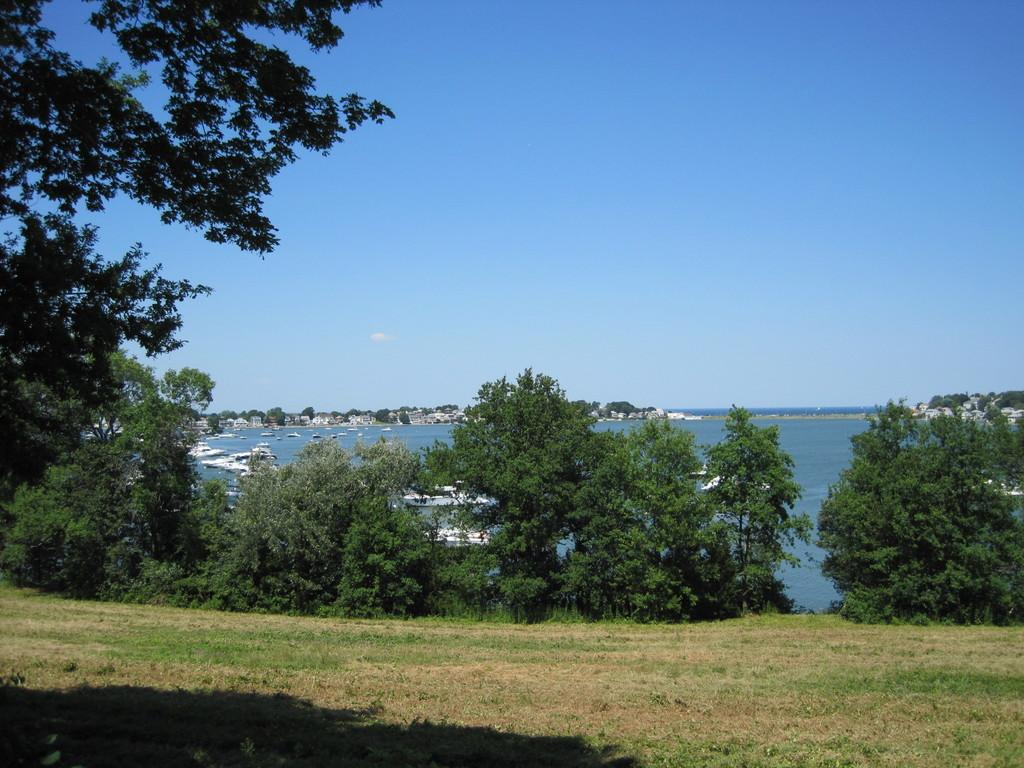What type of vegetation can be seen in the image? There are trees in the image. What is at the bottom of the image? There is grass at the bottom of the image. What can be seen floating on the water in the image? There are boats in the image. What is visible at the top of the image? The sky is visible at the top of the image. What is the primary body of water in the image? The water visible in the image is the primary body of water. Can you tell me what type of humor the stranger is using in the image? There is no stranger present in the image, so it is not possible to determine the type of humor being used. 